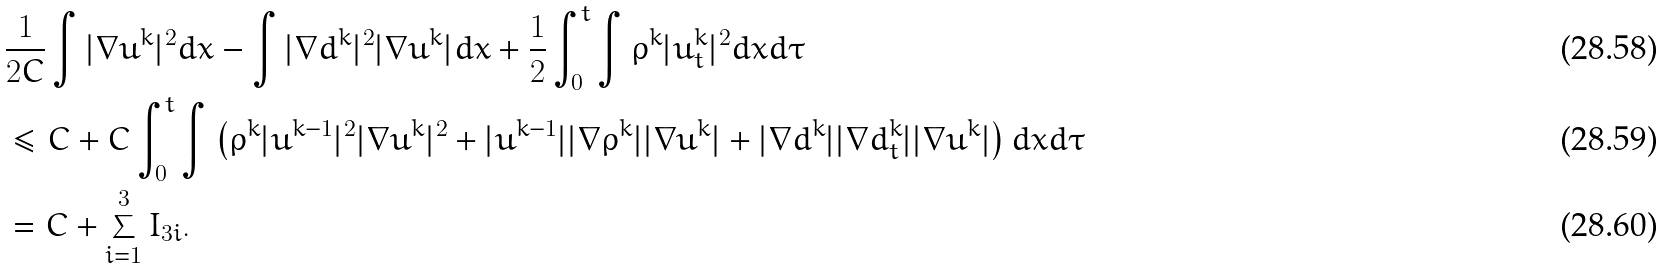<formula> <loc_0><loc_0><loc_500><loc_500>& \frac { 1 } { 2 C } \int | \nabla u ^ { k } | ^ { 2 } d x - \int | \nabla d ^ { k } | ^ { 2 } | \nabla u ^ { k } | d x + \frac { 1 } { 2 } \int _ { 0 } ^ { t } \int \rho ^ { k } | u _ { t } ^ { k } | ^ { 2 } d x d \tau \\ & \leq C + C \int _ { 0 } ^ { t } \int \left ( \rho ^ { k } | u ^ { k - 1 } | ^ { 2 } | \nabla u ^ { k } | ^ { 2 } + | u ^ { k - 1 } | | \nabla \rho ^ { k } | | \nabla u ^ { k } | + | \nabla d ^ { k } | | \nabla d _ { t } ^ { k } | | \nabla u ^ { k } | \right ) d x d \tau \\ & = C + \sum _ { i = 1 } ^ { 3 } I _ { 3 i } .</formula> 